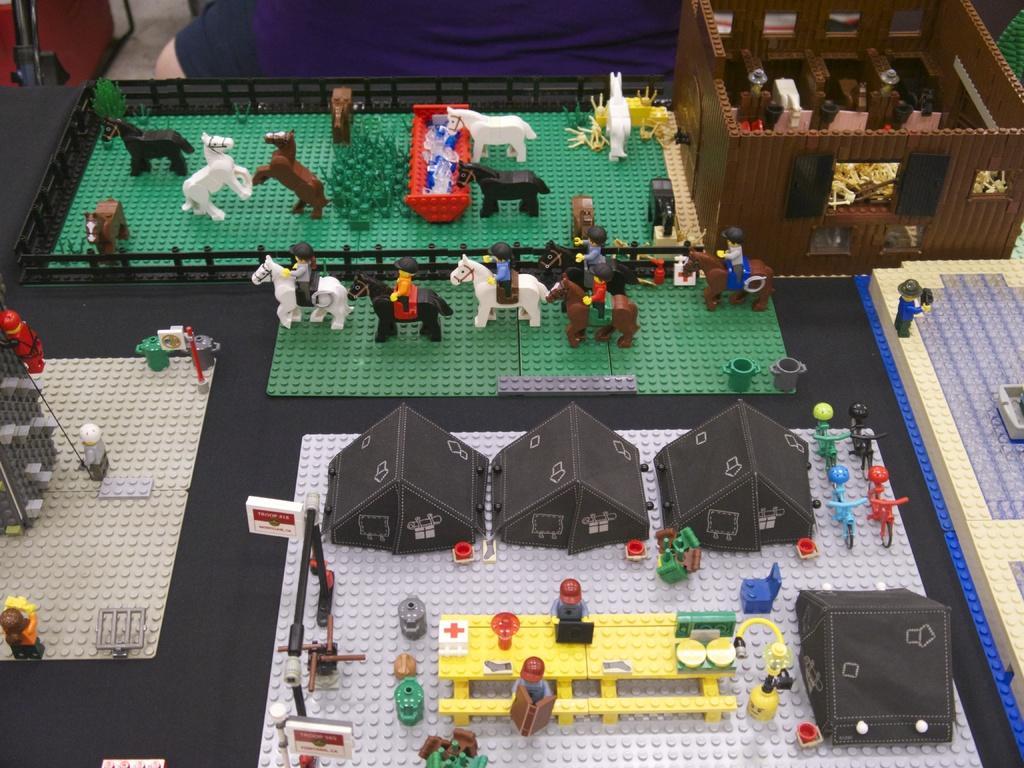Can you describe this image briefly? In this image, we can see toys on the board and in the background, there is a person and we can see a stand. 